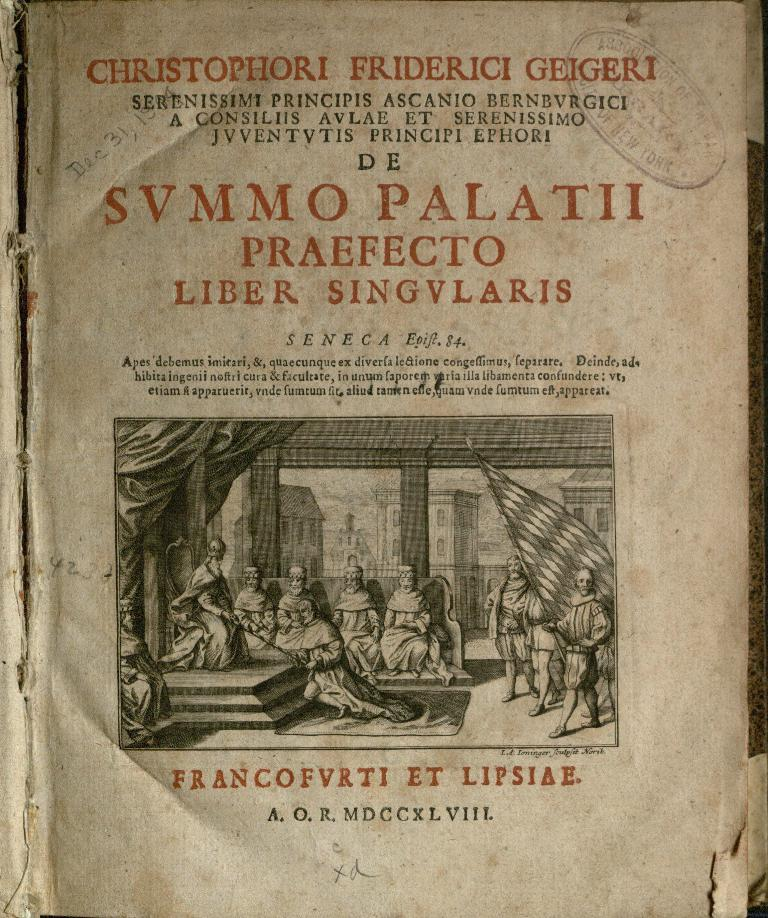<image>
Render a clear and concise summary of the photo. the front cover of svmmo palatii by christophori friderici geigeri 